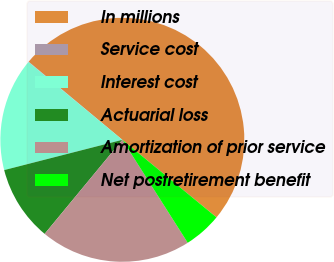Convert chart to OTSL. <chart><loc_0><loc_0><loc_500><loc_500><pie_chart><fcel>In millions<fcel>Service cost<fcel>Interest cost<fcel>Actuarial loss<fcel>Amortization of prior service<fcel>Net postretirement benefit<nl><fcel>49.9%<fcel>0.05%<fcel>15.0%<fcel>10.02%<fcel>19.99%<fcel>5.03%<nl></chart> 